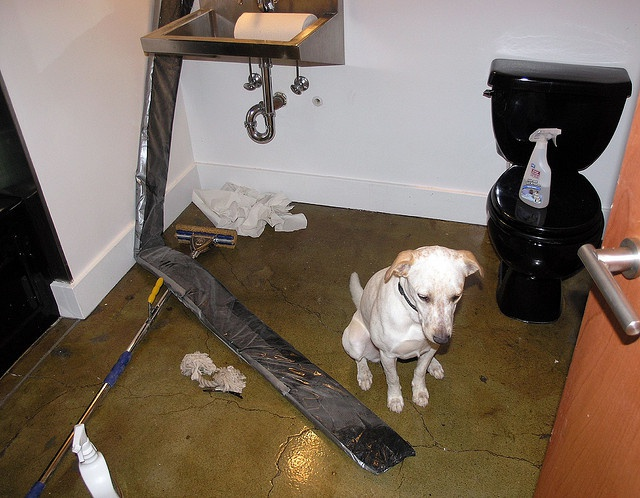Describe the objects in this image and their specific colors. I can see toilet in darkgray, black, and gray tones, dog in darkgray, lightgray, tan, and maroon tones, sink in darkgray, black, gray, and tan tones, and bottle in darkgray, black, and gray tones in this image. 